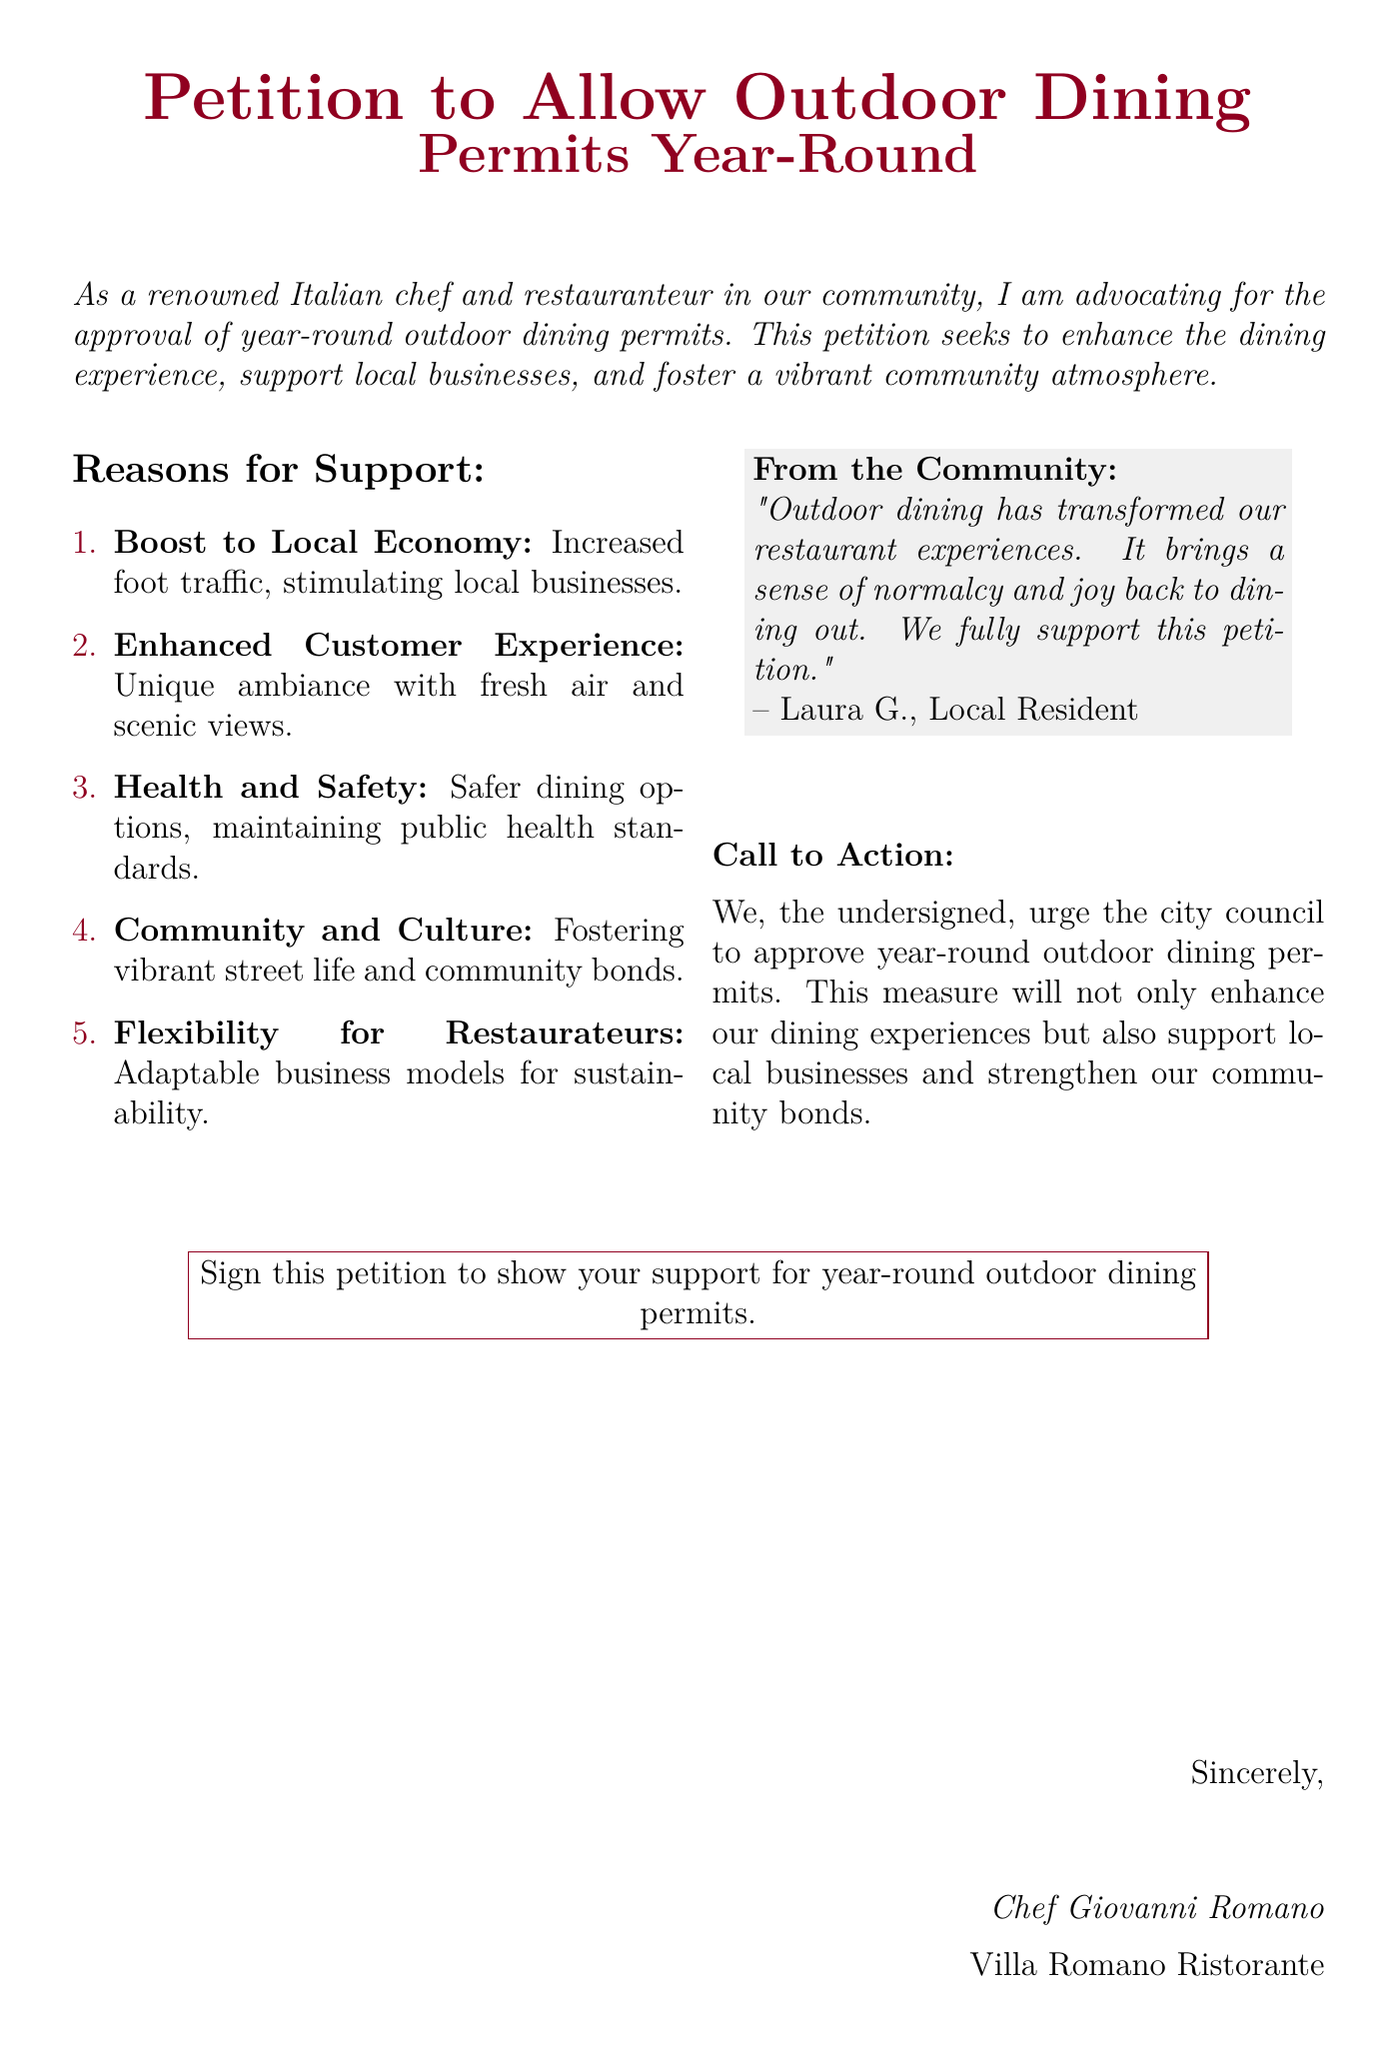What is the main goal of the petition? The goal of the petition is to advocate for the approval of year-round outdoor dining permits to enhance the dining experience.
Answer: Enhance the dining experience Who is the author of the petition? The author of the petition is the person who signed it, identified as Chef Giovanni Romano.
Answer: Chef Giovanni Romano How many reasons for support are listed in the document? The document lists a total of five reasons for support.
Answer: Five What color is used for the document's title? The color used for the title is winered.
Answer: Winered What is one reason mentioned for supporting outdoor dining? One reason mentioned is "Boost to Local Economy".
Answer: Boost to Local Economy What is the call to action in the document? The call to action urges the city council to approve year-round outdoor dining permits.
Answer: Approve year-round outdoor dining permits Who provided a quote from the community? A local resident, identified as Laura G., provided the quote.
Answer: Laura G What type of experience does outdoor dining aim to enhance according to the petition? Outdoor dining aims to enhance the customer experience, particularly by providing a unique ambiance.
Answer: Customer experience 